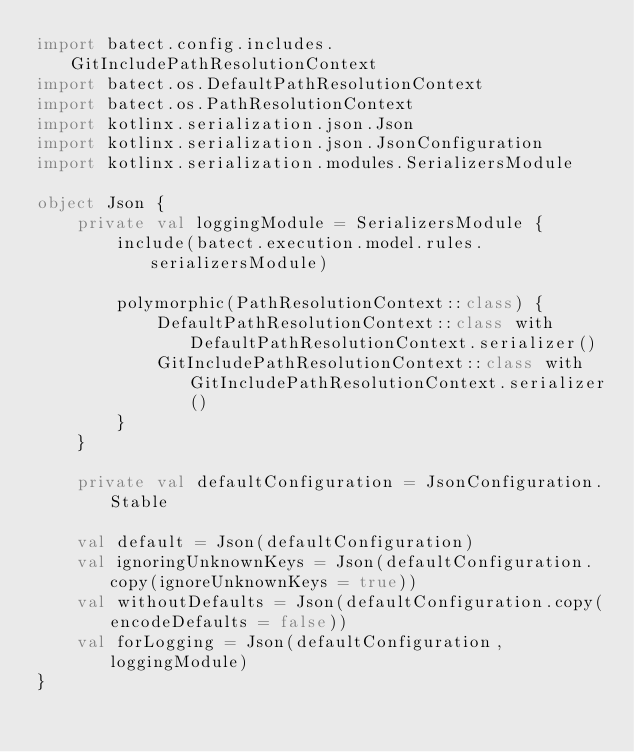Convert code to text. <code><loc_0><loc_0><loc_500><loc_500><_Kotlin_>import batect.config.includes.GitIncludePathResolutionContext
import batect.os.DefaultPathResolutionContext
import batect.os.PathResolutionContext
import kotlinx.serialization.json.Json
import kotlinx.serialization.json.JsonConfiguration
import kotlinx.serialization.modules.SerializersModule

object Json {
    private val loggingModule = SerializersModule {
        include(batect.execution.model.rules.serializersModule)

        polymorphic(PathResolutionContext::class) {
            DefaultPathResolutionContext::class with DefaultPathResolutionContext.serializer()
            GitIncludePathResolutionContext::class with GitIncludePathResolutionContext.serializer()
        }
    }

    private val defaultConfiguration = JsonConfiguration.Stable

    val default = Json(defaultConfiguration)
    val ignoringUnknownKeys = Json(defaultConfiguration.copy(ignoreUnknownKeys = true))
    val withoutDefaults = Json(defaultConfiguration.copy(encodeDefaults = false))
    val forLogging = Json(defaultConfiguration, loggingModule)
}
</code> 